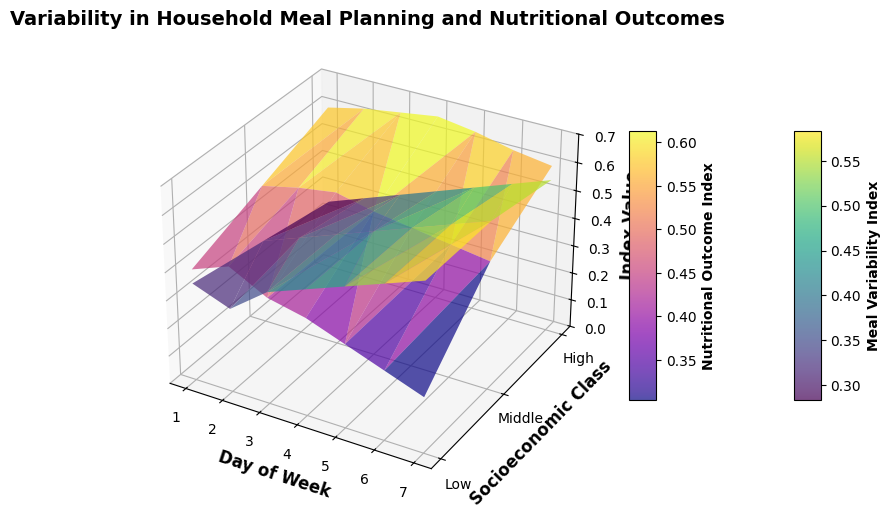What is the trend of the Meal Variability Index across the days of the week for the "Low" socioeconomic class? The trend for the Low class shows a gradual increase in the Meal Variability Index from day 1 to day 7. Specifically, it starts at around 0.35 on day 1 and increases to about 0.60 on day 7.
Answer: It gradually increases How do the Nutritional Outcome Index values compare between the "Middle" and "High" socioeconomic classes on day 4? By looking at day 4, the Nutritional Outcome Index for the Middle class is around 0.52, while for the High class, it is approximately 0.67. The High class has a higher Nutritional Outcome Index on day 4.
Answer: High > Middle Which socioeconomic class shows the highest Meal Variability Index on day 5? On day 5, the Low class has a Meal Variability Index of about 0.50, the Middle class also has 0.50, and the High class has 0.45. Both Low and Middle classes show the highest Meal Variability Index on day 5.
Answer: Low and Middle What is the average Nutritional Outcome Index for the Middle class across all days? The Nutritional Outcome Indexes for the Middle class are 0.50, 0.53, 0.55, 0.52, 0.50, 0.48, and 0.46. Summing these and dividing by 7 gives (0.50 + 0.53 + 0.55 + 0.52 + 0.50 + 0.48 + 0.46) / 7 ≈ 0.50.
Answer: 0.50 On which day does the "High" socioeconomic class show the greatest difference between the Meal Variability Index and the Nutritional Outcome Index? The greatest difference is calculated by finding the difference on each day: 1: 0.25-0.60= -0.35, 2: 0.30-0.63= -0.33, 3: 0.35-0.65= -0.30, 4: 0.40-0.67= -0.27, 5: 0.45-0.65= -0.20, 6: 0.50-0.62= -0.12, 7: 0.55-0.60= -0.05. The greatest difference is on day 1 and it is -0.35.
Answer: Day 1 How do the Meal Variability Index trends differ between the Low and High socioeconomic classes? The Meal Variability Index for both Low and High classes increases from day 1 to day 7, but the Low class starts at 0.35 and ends at 0.60, whereas the High class starts at 0.25 and ends at 0.55. The overall trend is the same, but the Low class has higher values throughout.
Answer: Low > High What is the difference in Nutritional Outcome Index between the "Low" and "Middle" classes on day 6? On day 6, the Nutritional Outcome Index for the Low class is about 0.25 and for the Middle class, it is about 0.48. The difference is 0.48 - 0.25 = 0.23.
Answer: 0.23 Which class shows more variability in the Meal Variability Index, and how do you quantify it? Variability can be quantified by the range (highest value - lowest value). For Low class: 0.60 - 0.35 = 0.25, for Middle: 0.60 - 0.30 = 0.30, for High: 0.55 - 0.25 = 0.30. Both Middle and High show more variability with a range of 0.30.
Answer: Middle and High, 0.30 What is the average Nutritional Outcome Index across all socioeconomic classes on day 1? The Nutritional Outcome Index on day 1 for Low is 0.40, for Middle is 0.50, and for High is 0.60. Adding these and dividing by 3 gives (0.40 + 0.50 + 0.60) / 3 ≈ 0.50.
Answer: 0.50 